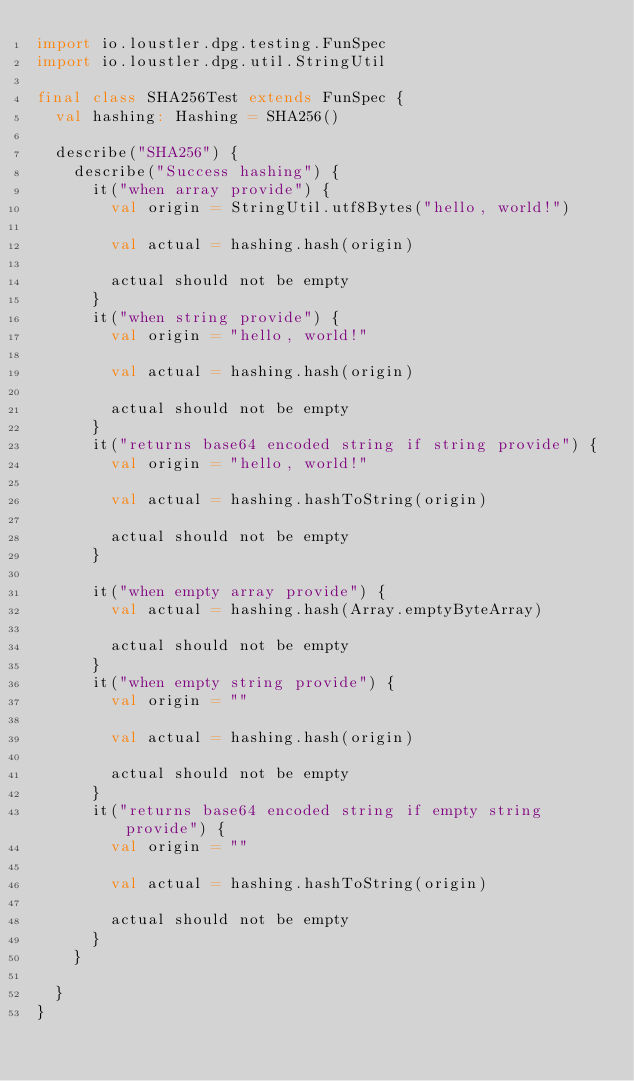<code> <loc_0><loc_0><loc_500><loc_500><_Scala_>import io.loustler.dpg.testing.FunSpec
import io.loustler.dpg.util.StringUtil

final class SHA256Test extends FunSpec {
  val hashing: Hashing = SHA256()

  describe("SHA256") {
    describe("Success hashing") {
      it("when array provide") {
        val origin = StringUtil.utf8Bytes("hello, world!")

        val actual = hashing.hash(origin)

        actual should not be empty
      }
      it("when string provide") {
        val origin = "hello, world!"

        val actual = hashing.hash(origin)

        actual should not be empty
      }
      it("returns base64 encoded string if string provide") {
        val origin = "hello, world!"

        val actual = hashing.hashToString(origin)

        actual should not be empty
      }

      it("when empty array provide") {
        val actual = hashing.hash(Array.emptyByteArray)

        actual should not be empty
      }
      it("when empty string provide") {
        val origin = ""

        val actual = hashing.hash(origin)

        actual should not be empty
      }
      it("returns base64 encoded string if empty string provide") {
        val origin = ""

        val actual = hashing.hashToString(origin)

        actual should not be empty
      }
    }

  }
}
</code> 